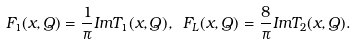<formula> <loc_0><loc_0><loc_500><loc_500>F _ { 1 } ( x , Q ) = \frac { 1 } { \pi } I m T _ { 1 } ( x , Q ) , \ F _ { L } ( x , Q ) = \frac { 8 } { \pi } I m T _ { 2 } ( x , Q ) .</formula> 